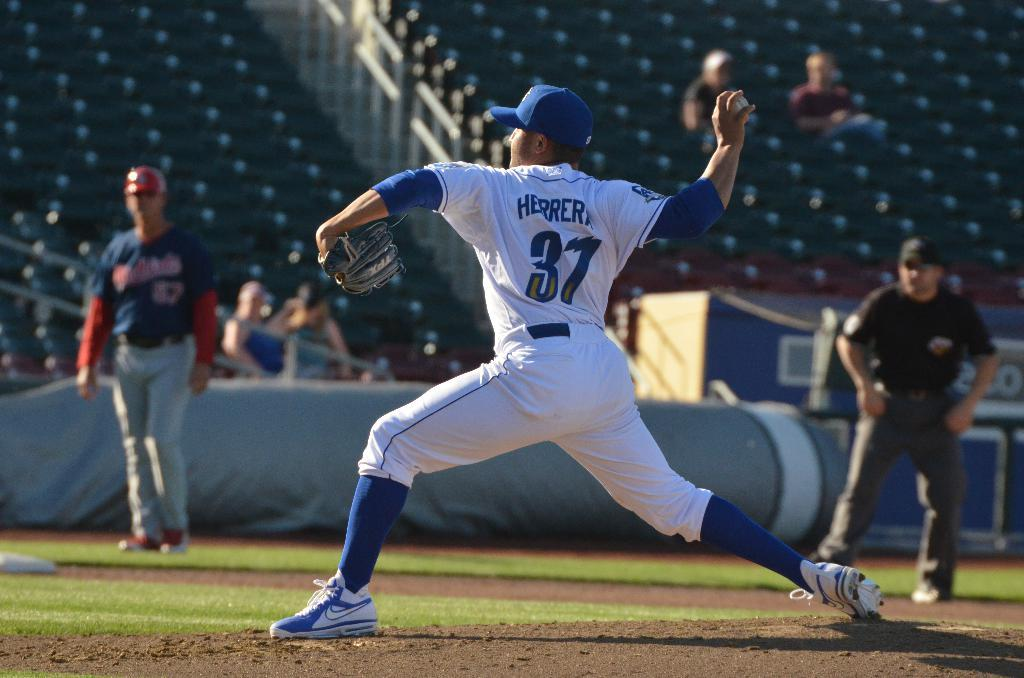<image>
Give a short and clear explanation of the subsequent image. A baseball pitcher with the number 37 and the name Herrera on the back of his jersey throws a pitch. 